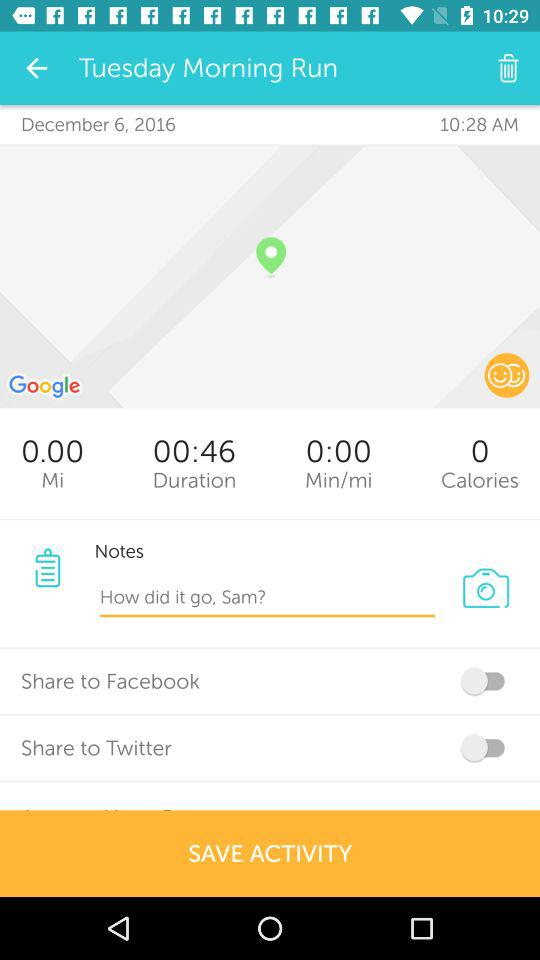How many calories are burned? There are 0 burned calories. 